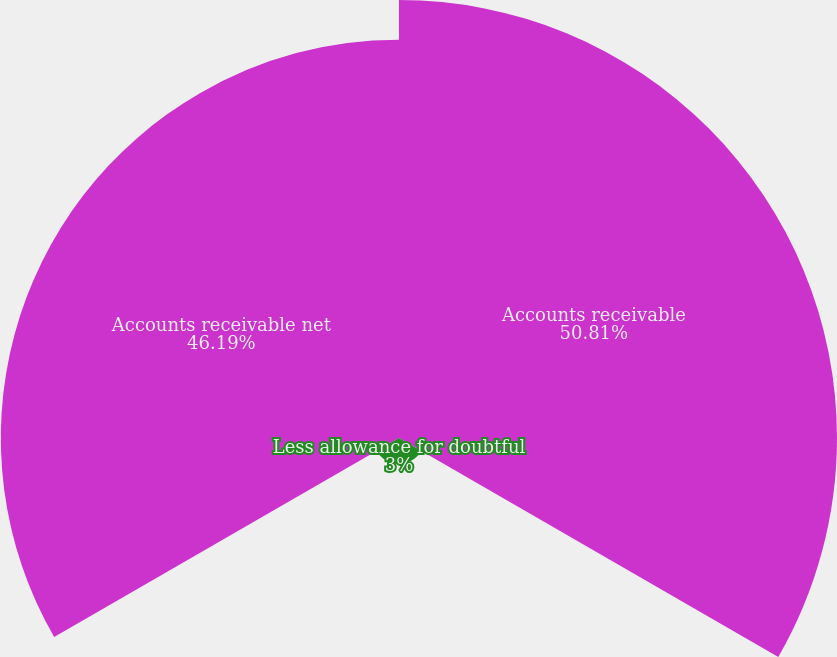Convert chart to OTSL. <chart><loc_0><loc_0><loc_500><loc_500><pie_chart><fcel>Accounts receivable<fcel>Less allowance for doubtful<fcel>Accounts receivable net<nl><fcel>50.81%<fcel>3.0%<fcel>46.19%<nl></chart> 